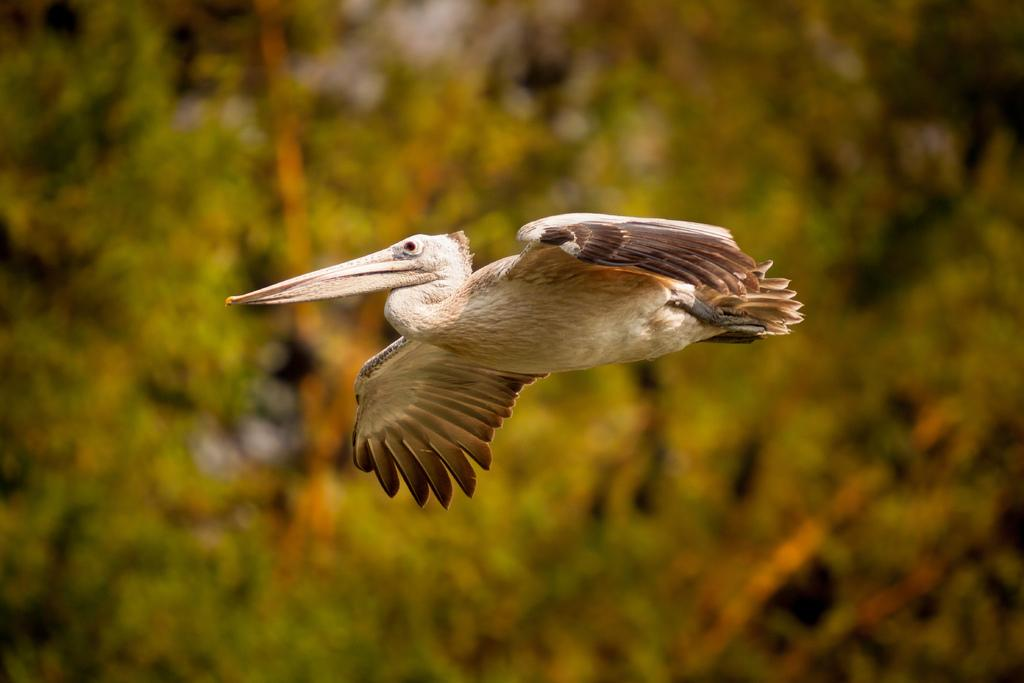What is the main subject of the image? The main subject of the image is a bird flying. Can you describe the bird's activity in the image? The bird is flying in the image. What might be visible in the background of the image? There may be trees in the background of the image. What type of meat is being cooked in the image? There is no meat or cooking activity present in the image; it features a bird flying. How does the bird cover its stomach while flying in the image? Birds do not have the ability to cover their stomachs while flying, and there is no indication of such behavior in the image. 